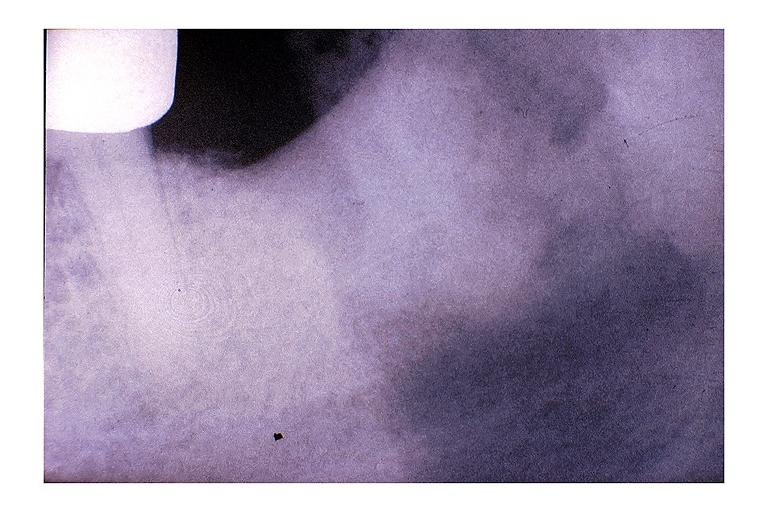what does this image show?
Answer the question using a single word or phrase. Chronic osteomyelitis 